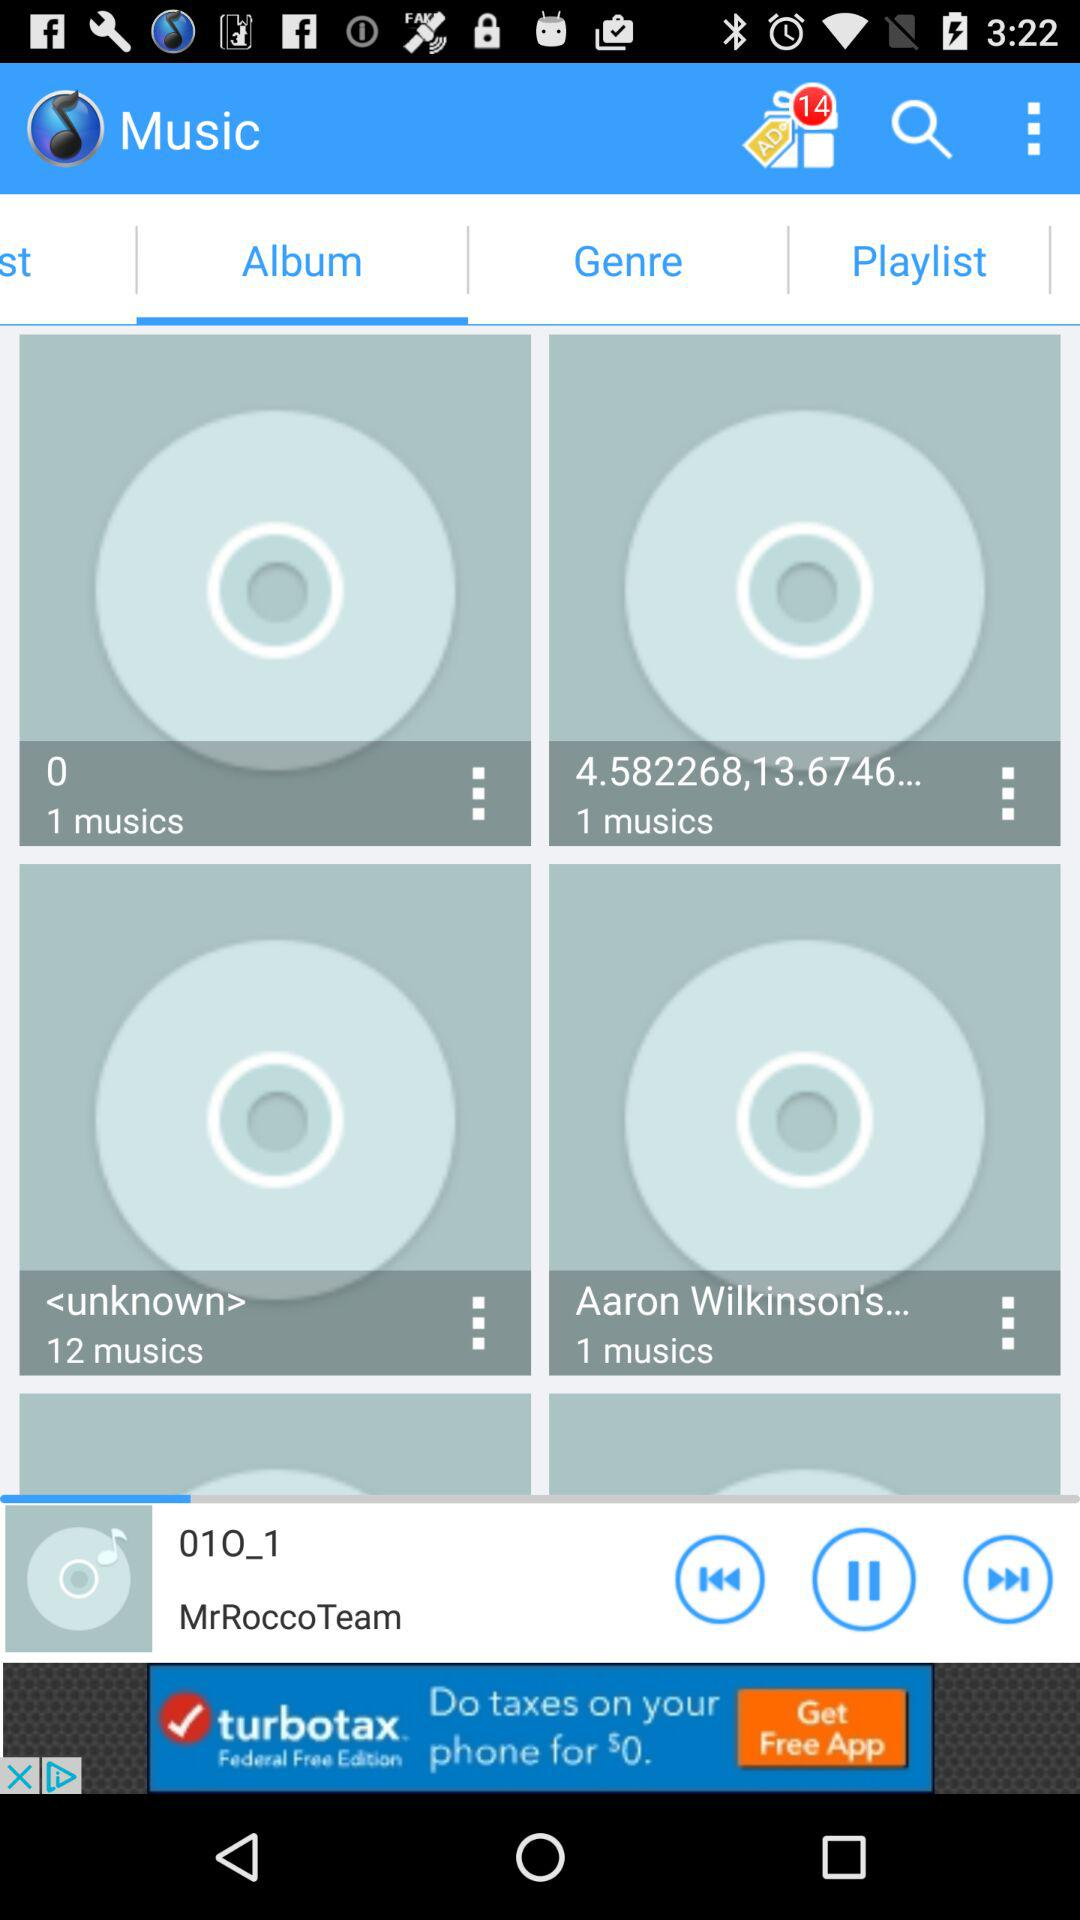Which tab is currently selected? The selected tab is "Album". 